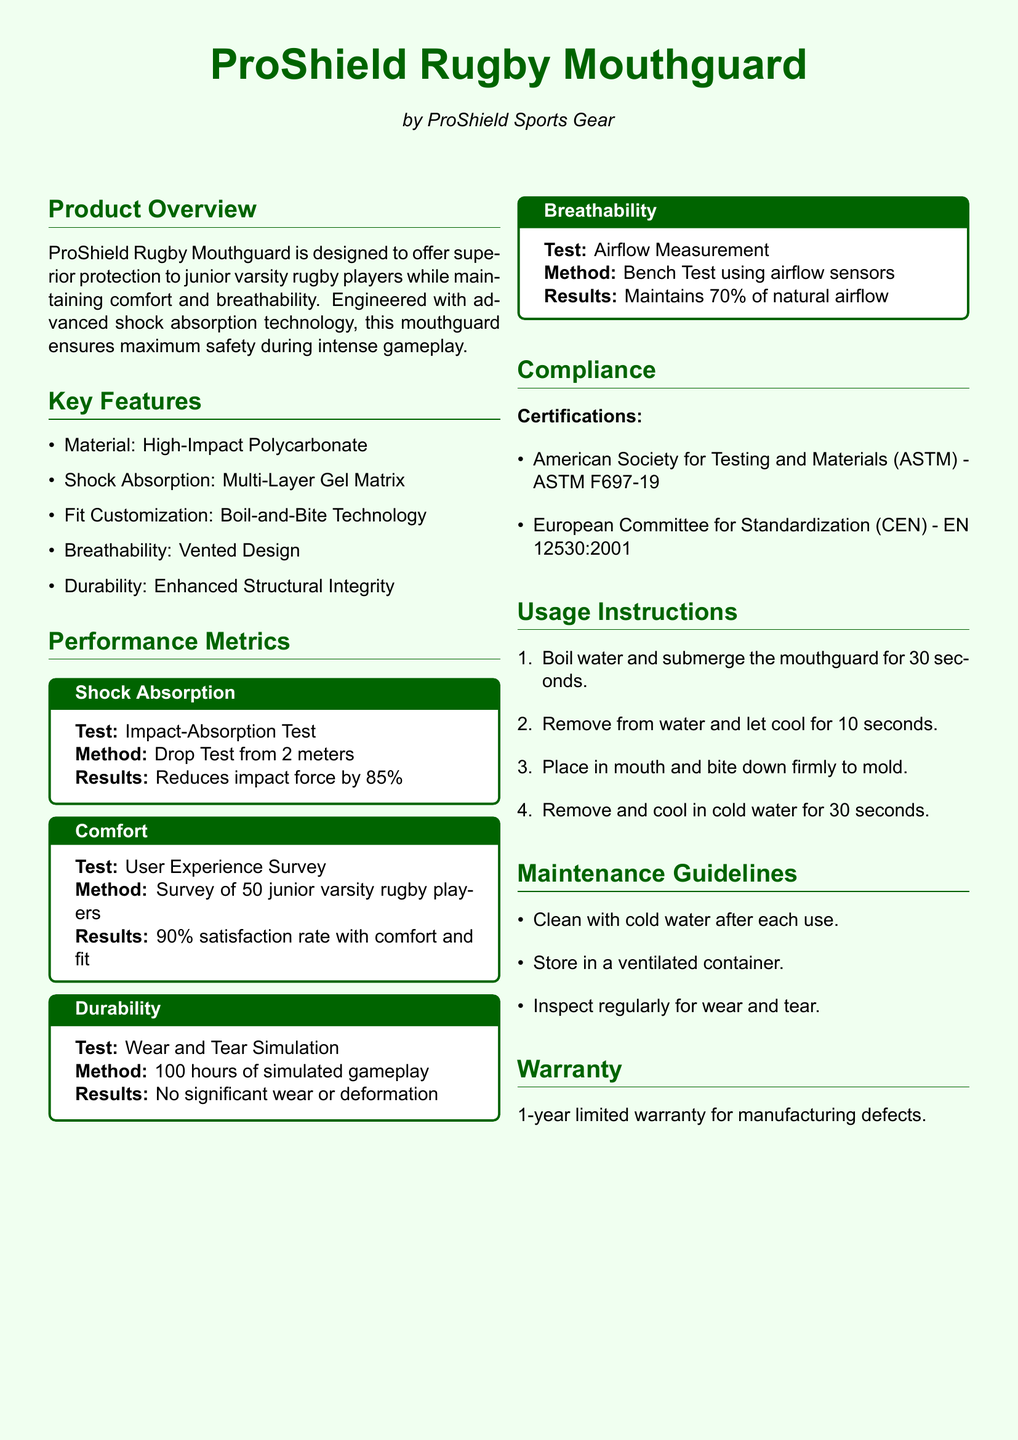what material is the mouthguard made of? The material is specified in the Key Features section as High-Impact Polycarbonate.
Answer: High-Impact Polycarbonate what percentage does the mouthguard reduce impact force by? The performance metric under Shock Absorption states that it reduces impact force by 85%.
Answer: 85% how many junior varsity rugby players participated in the user experience survey? The Comfort feature box mentions a survey of 50 junior varsity rugby players.
Answer: 50 what is the satisfaction rate with comfort and fit? According to the Results in the Comfort feature box, it states a 90% satisfaction rate with comfort and fit.
Answer: 90% what is the maintenance guideline for cleaning? The document specifies cleaning with cold water after each use as a maintenance guideline.
Answer: Cold water how long is the warranty period for the mouthguard? The warranty section mentions a 1-year limited warranty for manufacturing defects.
Answer: 1-year what does the airflow measurement result indicate? The Breachability feature box states that it maintains 70% of natural airflow.
Answer: 70% what testing method was used for the wear and tear simulation? The Durability feature box states a method of 100 hours of simulated gameplay for testing wear and tear.
Answer: 100 hours what specific certification does the mouthguard meet according to the ASTM? The Compliance section lists ASTM F697-19 as the certification from the American Society for Testing and Materials.
Answer: ASTM F697-19 